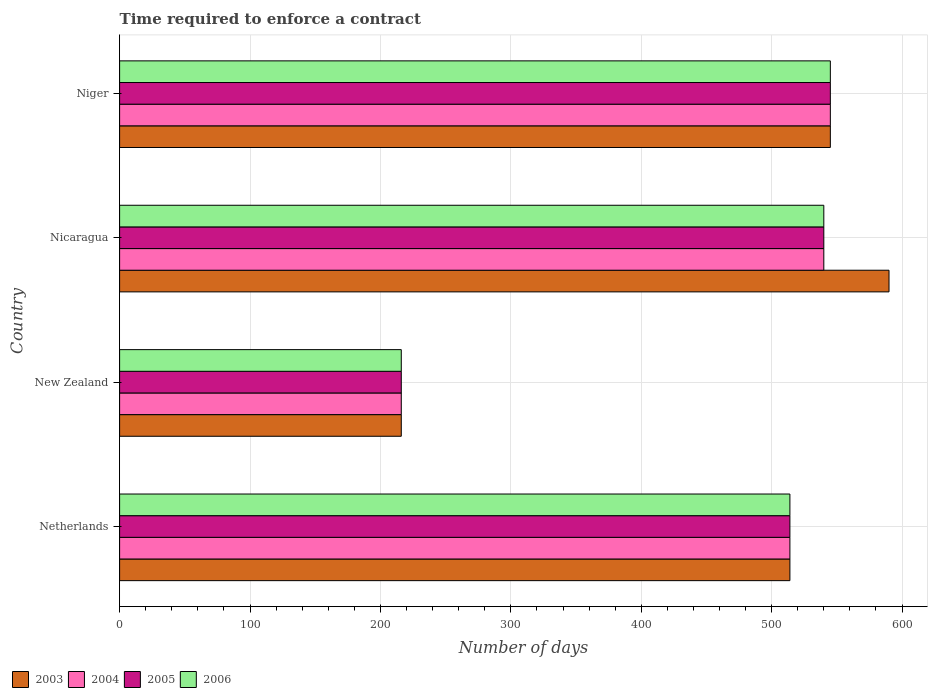How many bars are there on the 2nd tick from the bottom?
Make the answer very short. 4. What is the label of the 3rd group of bars from the top?
Your answer should be compact. New Zealand. What is the number of days required to enforce a contract in 2003 in New Zealand?
Ensure brevity in your answer.  216. Across all countries, what is the maximum number of days required to enforce a contract in 2005?
Ensure brevity in your answer.  545. Across all countries, what is the minimum number of days required to enforce a contract in 2004?
Make the answer very short. 216. In which country was the number of days required to enforce a contract in 2005 maximum?
Make the answer very short. Niger. In which country was the number of days required to enforce a contract in 2005 minimum?
Offer a very short reply. New Zealand. What is the total number of days required to enforce a contract in 2006 in the graph?
Keep it short and to the point. 1815. What is the difference between the number of days required to enforce a contract in 2004 in Netherlands and that in Niger?
Ensure brevity in your answer.  -31. What is the difference between the number of days required to enforce a contract in 2004 in Nicaragua and the number of days required to enforce a contract in 2006 in New Zealand?
Your answer should be compact. 324. What is the average number of days required to enforce a contract in 2005 per country?
Ensure brevity in your answer.  453.75. What is the ratio of the number of days required to enforce a contract in 2003 in New Zealand to that in Niger?
Ensure brevity in your answer.  0.4. Is the number of days required to enforce a contract in 2005 in New Zealand less than that in Nicaragua?
Keep it short and to the point. Yes. Is the difference between the number of days required to enforce a contract in 2004 in Netherlands and Nicaragua greater than the difference between the number of days required to enforce a contract in 2006 in Netherlands and Nicaragua?
Provide a succinct answer. No. What is the difference between the highest and the second highest number of days required to enforce a contract in 2003?
Your response must be concise. 45. What is the difference between the highest and the lowest number of days required to enforce a contract in 2005?
Keep it short and to the point. 329. Is it the case that in every country, the sum of the number of days required to enforce a contract in 2004 and number of days required to enforce a contract in 2006 is greater than the sum of number of days required to enforce a contract in 2005 and number of days required to enforce a contract in 2003?
Your response must be concise. No. What does the 2nd bar from the top in Netherlands represents?
Make the answer very short. 2005. What does the 4th bar from the bottom in Niger represents?
Provide a succinct answer. 2006. How many bars are there?
Provide a succinct answer. 16. Are all the bars in the graph horizontal?
Make the answer very short. Yes. Are the values on the major ticks of X-axis written in scientific E-notation?
Ensure brevity in your answer.  No. How many legend labels are there?
Keep it short and to the point. 4. How are the legend labels stacked?
Make the answer very short. Horizontal. What is the title of the graph?
Offer a very short reply. Time required to enforce a contract. Does "1994" appear as one of the legend labels in the graph?
Ensure brevity in your answer.  No. What is the label or title of the X-axis?
Provide a succinct answer. Number of days. What is the label or title of the Y-axis?
Your answer should be compact. Country. What is the Number of days of 2003 in Netherlands?
Make the answer very short. 514. What is the Number of days in 2004 in Netherlands?
Keep it short and to the point. 514. What is the Number of days in 2005 in Netherlands?
Provide a short and direct response. 514. What is the Number of days of 2006 in Netherlands?
Offer a terse response. 514. What is the Number of days of 2003 in New Zealand?
Offer a very short reply. 216. What is the Number of days of 2004 in New Zealand?
Ensure brevity in your answer.  216. What is the Number of days in 2005 in New Zealand?
Your answer should be compact. 216. What is the Number of days of 2006 in New Zealand?
Offer a very short reply. 216. What is the Number of days of 2003 in Nicaragua?
Keep it short and to the point. 590. What is the Number of days of 2004 in Nicaragua?
Give a very brief answer. 540. What is the Number of days in 2005 in Nicaragua?
Your answer should be very brief. 540. What is the Number of days in 2006 in Nicaragua?
Offer a very short reply. 540. What is the Number of days in 2003 in Niger?
Give a very brief answer. 545. What is the Number of days of 2004 in Niger?
Provide a succinct answer. 545. What is the Number of days in 2005 in Niger?
Keep it short and to the point. 545. What is the Number of days of 2006 in Niger?
Offer a very short reply. 545. Across all countries, what is the maximum Number of days of 2003?
Provide a succinct answer. 590. Across all countries, what is the maximum Number of days in 2004?
Make the answer very short. 545. Across all countries, what is the maximum Number of days in 2005?
Your response must be concise. 545. Across all countries, what is the maximum Number of days in 2006?
Give a very brief answer. 545. Across all countries, what is the minimum Number of days in 2003?
Keep it short and to the point. 216. Across all countries, what is the minimum Number of days of 2004?
Provide a short and direct response. 216. Across all countries, what is the minimum Number of days in 2005?
Offer a terse response. 216. Across all countries, what is the minimum Number of days in 2006?
Your answer should be very brief. 216. What is the total Number of days in 2003 in the graph?
Keep it short and to the point. 1865. What is the total Number of days in 2004 in the graph?
Make the answer very short. 1815. What is the total Number of days of 2005 in the graph?
Provide a succinct answer. 1815. What is the total Number of days of 2006 in the graph?
Your response must be concise. 1815. What is the difference between the Number of days in 2003 in Netherlands and that in New Zealand?
Your response must be concise. 298. What is the difference between the Number of days of 2004 in Netherlands and that in New Zealand?
Your answer should be very brief. 298. What is the difference between the Number of days of 2005 in Netherlands and that in New Zealand?
Give a very brief answer. 298. What is the difference between the Number of days in 2006 in Netherlands and that in New Zealand?
Offer a very short reply. 298. What is the difference between the Number of days of 2003 in Netherlands and that in Nicaragua?
Your answer should be very brief. -76. What is the difference between the Number of days in 2004 in Netherlands and that in Nicaragua?
Your answer should be very brief. -26. What is the difference between the Number of days in 2003 in Netherlands and that in Niger?
Keep it short and to the point. -31. What is the difference between the Number of days in 2004 in Netherlands and that in Niger?
Give a very brief answer. -31. What is the difference between the Number of days in 2005 in Netherlands and that in Niger?
Provide a succinct answer. -31. What is the difference between the Number of days of 2006 in Netherlands and that in Niger?
Your response must be concise. -31. What is the difference between the Number of days of 2003 in New Zealand and that in Nicaragua?
Your response must be concise. -374. What is the difference between the Number of days in 2004 in New Zealand and that in Nicaragua?
Your response must be concise. -324. What is the difference between the Number of days of 2005 in New Zealand and that in Nicaragua?
Provide a succinct answer. -324. What is the difference between the Number of days of 2006 in New Zealand and that in Nicaragua?
Ensure brevity in your answer.  -324. What is the difference between the Number of days of 2003 in New Zealand and that in Niger?
Give a very brief answer. -329. What is the difference between the Number of days in 2004 in New Zealand and that in Niger?
Ensure brevity in your answer.  -329. What is the difference between the Number of days of 2005 in New Zealand and that in Niger?
Ensure brevity in your answer.  -329. What is the difference between the Number of days of 2006 in New Zealand and that in Niger?
Make the answer very short. -329. What is the difference between the Number of days of 2003 in Nicaragua and that in Niger?
Offer a terse response. 45. What is the difference between the Number of days of 2003 in Netherlands and the Number of days of 2004 in New Zealand?
Your response must be concise. 298. What is the difference between the Number of days in 2003 in Netherlands and the Number of days in 2005 in New Zealand?
Provide a succinct answer. 298. What is the difference between the Number of days of 2003 in Netherlands and the Number of days of 2006 in New Zealand?
Your answer should be very brief. 298. What is the difference between the Number of days in 2004 in Netherlands and the Number of days in 2005 in New Zealand?
Make the answer very short. 298. What is the difference between the Number of days in 2004 in Netherlands and the Number of days in 2006 in New Zealand?
Give a very brief answer. 298. What is the difference between the Number of days in 2005 in Netherlands and the Number of days in 2006 in New Zealand?
Keep it short and to the point. 298. What is the difference between the Number of days in 2003 in Netherlands and the Number of days in 2004 in Nicaragua?
Give a very brief answer. -26. What is the difference between the Number of days in 2003 in Netherlands and the Number of days in 2006 in Nicaragua?
Your response must be concise. -26. What is the difference between the Number of days of 2004 in Netherlands and the Number of days of 2005 in Nicaragua?
Provide a short and direct response. -26. What is the difference between the Number of days of 2003 in Netherlands and the Number of days of 2004 in Niger?
Ensure brevity in your answer.  -31. What is the difference between the Number of days in 2003 in Netherlands and the Number of days in 2005 in Niger?
Your response must be concise. -31. What is the difference between the Number of days of 2003 in Netherlands and the Number of days of 2006 in Niger?
Offer a very short reply. -31. What is the difference between the Number of days of 2004 in Netherlands and the Number of days of 2005 in Niger?
Ensure brevity in your answer.  -31. What is the difference between the Number of days in 2004 in Netherlands and the Number of days in 2006 in Niger?
Offer a very short reply. -31. What is the difference between the Number of days in 2005 in Netherlands and the Number of days in 2006 in Niger?
Offer a very short reply. -31. What is the difference between the Number of days in 2003 in New Zealand and the Number of days in 2004 in Nicaragua?
Keep it short and to the point. -324. What is the difference between the Number of days of 2003 in New Zealand and the Number of days of 2005 in Nicaragua?
Your answer should be compact. -324. What is the difference between the Number of days in 2003 in New Zealand and the Number of days in 2006 in Nicaragua?
Make the answer very short. -324. What is the difference between the Number of days in 2004 in New Zealand and the Number of days in 2005 in Nicaragua?
Provide a short and direct response. -324. What is the difference between the Number of days of 2004 in New Zealand and the Number of days of 2006 in Nicaragua?
Make the answer very short. -324. What is the difference between the Number of days of 2005 in New Zealand and the Number of days of 2006 in Nicaragua?
Keep it short and to the point. -324. What is the difference between the Number of days of 2003 in New Zealand and the Number of days of 2004 in Niger?
Your answer should be compact. -329. What is the difference between the Number of days in 2003 in New Zealand and the Number of days in 2005 in Niger?
Provide a short and direct response. -329. What is the difference between the Number of days of 2003 in New Zealand and the Number of days of 2006 in Niger?
Offer a terse response. -329. What is the difference between the Number of days of 2004 in New Zealand and the Number of days of 2005 in Niger?
Provide a succinct answer. -329. What is the difference between the Number of days in 2004 in New Zealand and the Number of days in 2006 in Niger?
Keep it short and to the point. -329. What is the difference between the Number of days of 2005 in New Zealand and the Number of days of 2006 in Niger?
Ensure brevity in your answer.  -329. What is the difference between the Number of days in 2004 in Nicaragua and the Number of days in 2006 in Niger?
Your answer should be compact. -5. What is the difference between the Number of days in 2005 in Nicaragua and the Number of days in 2006 in Niger?
Ensure brevity in your answer.  -5. What is the average Number of days in 2003 per country?
Ensure brevity in your answer.  466.25. What is the average Number of days in 2004 per country?
Your answer should be very brief. 453.75. What is the average Number of days of 2005 per country?
Give a very brief answer. 453.75. What is the average Number of days in 2006 per country?
Make the answer very short. 453.75. What is the difference between the Number of days in 2003 and Number of days in 2005 in Netherlands?
Your answer should be compact. 0. What is the difference between the Number of days in 2004 and Number of days in 2006 in Netherlands?
Give a very brief answer. 0. What is the difference between the Number of days in 2003 and Number of days in 2004 in New Zealand?
Provide a short and direct response. 0. What is the difference between the Number of days in 2003 and Number of days in 2005 in New Zealand?
Your answer should be very brief. 0. What is the difference between the Number of days in 2003 and Number of days in 2006 in New Zealand?
Provide a short and direct response. 0. What is the difference between the Number of days in 2004 and Number of days in 2005 in New Zealand?
Provide a succinct answer. 0. What is the difference between the Number of days in 2005 and Number of days in 2006 in New Zealand?
Provide a succinct answer. 0. What is the difference between the Number of days of 2003 and Number of days of 2004 in Nicaragua?
Your answer should be compact. 50. What is the difference between the Number of days of 2003 and Number of days of 2006 in Nicaragua?
Your response must be concise. 50. What is the difference between the Number of days in 2004 and Number of days in 2005 in Nicaragua?
Provide a short and direct response. 0. What is the difference between the Number of days of 2005 and Number of days of 2006 in Nicaragua?
Provide a short and direct response. 0. What is the difference between the Number of days of 2003 and Number of days of 2006 in Niger?
Provide a succinct answer. 0. What is the difference between the Number of days of 2004 and Number of days of 2005 in Niger?
Provide a short and direct response. 0. What is the difference between the Number of days of 2005 and Number of days of 2006 in Niger?
Make the answer very short. 0. What is the ratio of the Number of days in 2003 in Netherlands to that in New Zealand?
Provide a short and direct response. 2.38. What is the ratio of the Number of days in 2004 in Netherlands to that in New Zealand?
Give a very brief answer. 2.38. What is the ratio of the Number of days of 2005 in Netherlands to that in New Zealand?
Provide a short and direct response. 2.38. What is the ratio of the Number of days in 2006 in Netherlands to that in New Zealand?
Keep it short and to the point. 2.38. What is the ratio of the Number of days of 2003 in Netherlands to that in Nicaragua?
Offer a very short reply. 0.87. What is the ratio of the Number of days of 2004 in Netherlands to that in Nicaragua?
Your answer should be compact. 0.95. What is the ratio of the Number of days in 2005 in Netherlands to that in Nicaragua?
Ensure brevity in your answer.  0.95. What is the ratio of the Number of days of 2006 in Netherlands to that in Nicaragua?
Ensure brevity in your answer.  0.95. What is the ratio of the Number of days of 2003 in Netherlands to that in Niger?
Your answer should be compact. 0.94. What is the ratio of the Number of days in 2004 in Netherlands to that in Niger?
Offer a terse response. 0.94. What is the ratio of the Number of days of 2005 in Netherlands to that in Niger?
Ensure brevity in your answer.  0.94. What is the ratio of the Number of days in 2006 in Netherlands to that in Niger?
Offer a very short reply. 0.94. What is the ratio of the Number of days of 2003 in New Zealand to that in Nicaragua?
Your answer should be very brief. 0.37. What is the ratio of the Number of days in 2004 in New Zealand to that in Nicaragua?
Your answer should be very brief. 0.4. What is the ratio of the Number of days of 2003 in New Zealand to that in Niger?
Provide a succinct answer. 0.4. What is the ratio of the Number of days of 2004 in New Zealand to that in Niger?
Your answer should be very brief. 0.4. What is the ratio of the Number of days of 2005 in New Zealand to that in Niger?
Keep it short and to the point. 0.4. What is the ratio of the Number of days in 2006 in New Zealand to that in Niger?
Give a very brief answer. 0.4. What is the ratio of the Number of days of 2003 in Nicaragua to that in Niger?
Offer a very short reply. 1.08. What is the ratio of the Number of days of 2004 in Nicaragua to that in Niger?
Make the answer very short. 0.99. What is the difference between the highest and the second highest Number of days in 2005?
Ensure brevity in your answer.  5. What is the difference between the highest and the second highest Number of days in 2006?
Keep it short and to the point. 5. What is the difference between the highest and the lowest Number of days of 2003?
Provide a succinct answer. 374. What is the difference between the highest and the lowest Number of days in 2004?
Offer a very short reply. 329. What is the difference between the highest and the lowest Number of days of 2005?
Your answer should be very brief. 329. What is the difference between the highest and the lowest Number of days in 2006?
Your answer should be very brief. 329. 